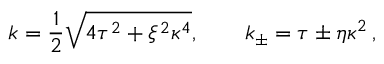Convert formula to latex. <formula><loc_0><loc_0><loc_500><loc_500>k = \frac { 1 } { 2 } \sqrt { 4 \tau ^ { 2 } + \xi ^ { 2 } \kappa ^ { 4 } } , \quad k _ { \pm } = \tau \pm \eta \kappa ^ { 2 } \, ,</formula> 